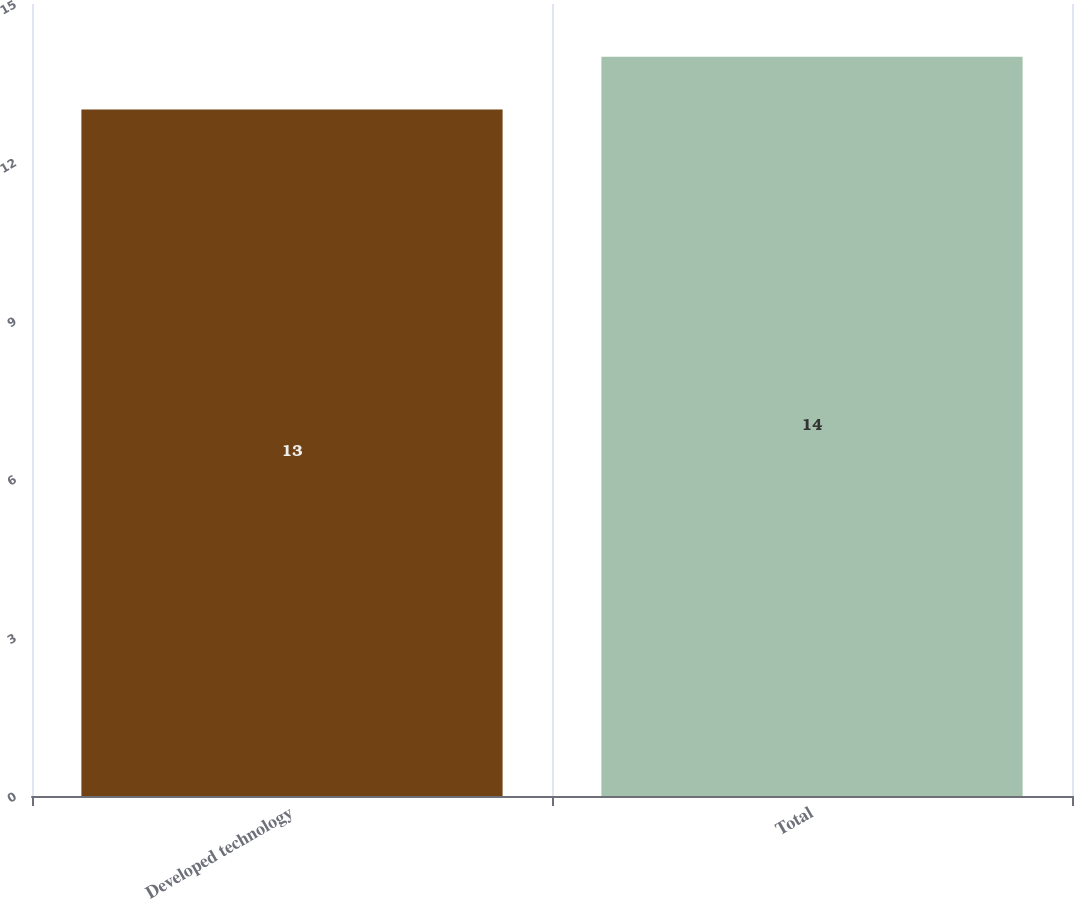Convert chart to OTSL. <chart><loc_0><loc_0><loc_500><loc_500><bar_chart><fcel>Developed technology<fcel>Total<nl><fcel>13<fcel>14<nl></chart> 